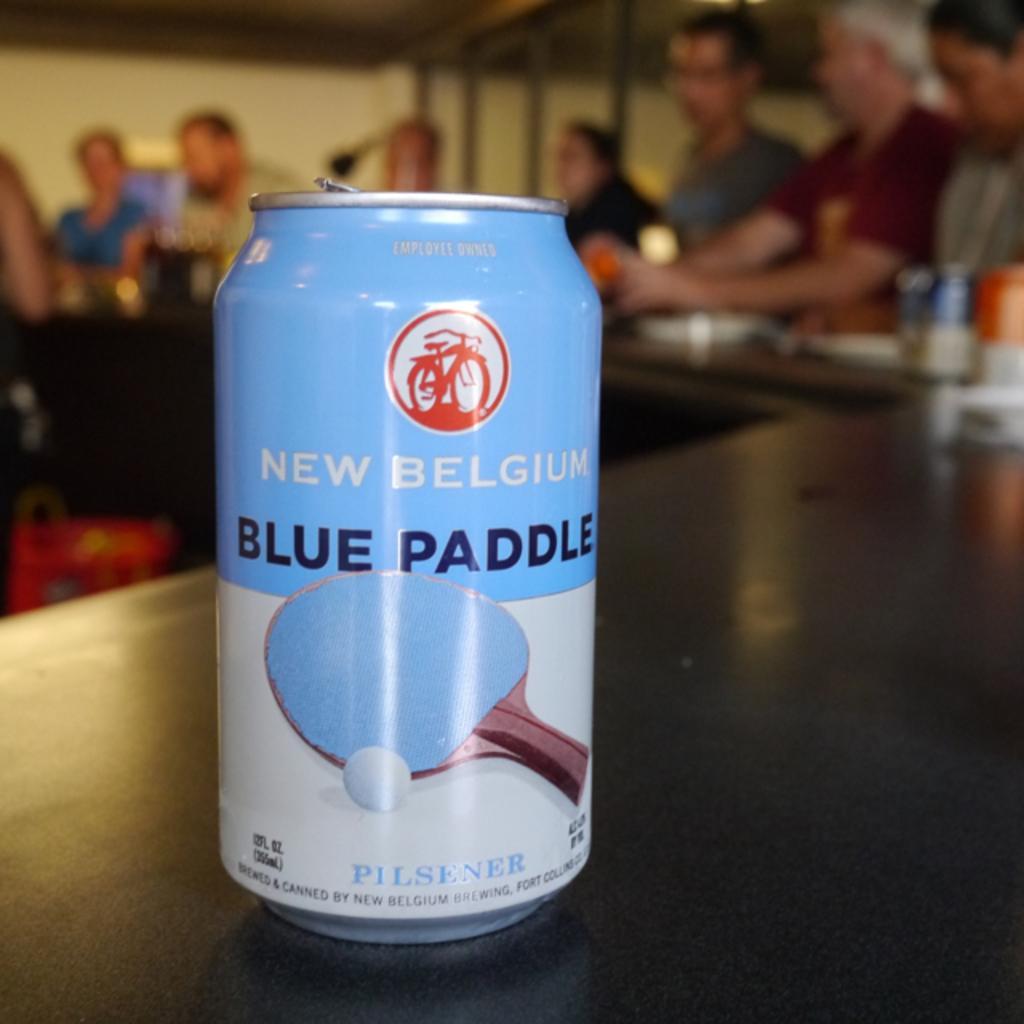In one or two sentences, can you explain what this image depicts? In this image we can see a tin. In the background of the image there are some persons, wall, glass windows and other objects. At the bottom of the image there is a black surface. 